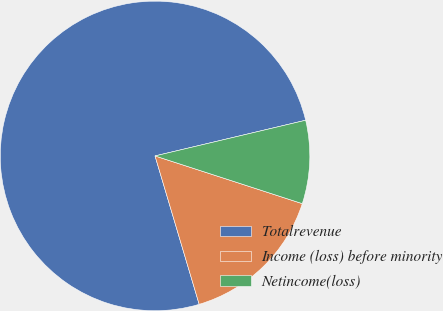Convert chart. <chart><loc_0><loc_0><loc_500><loc_500><pie_chart><fcel>Totalrevenue<fcel>Income (loss) before minority<fcel>Netincome(loss)<nl><fcel>75.9%<fcel>15.41%<fcel>8.69%<nl></chart> 